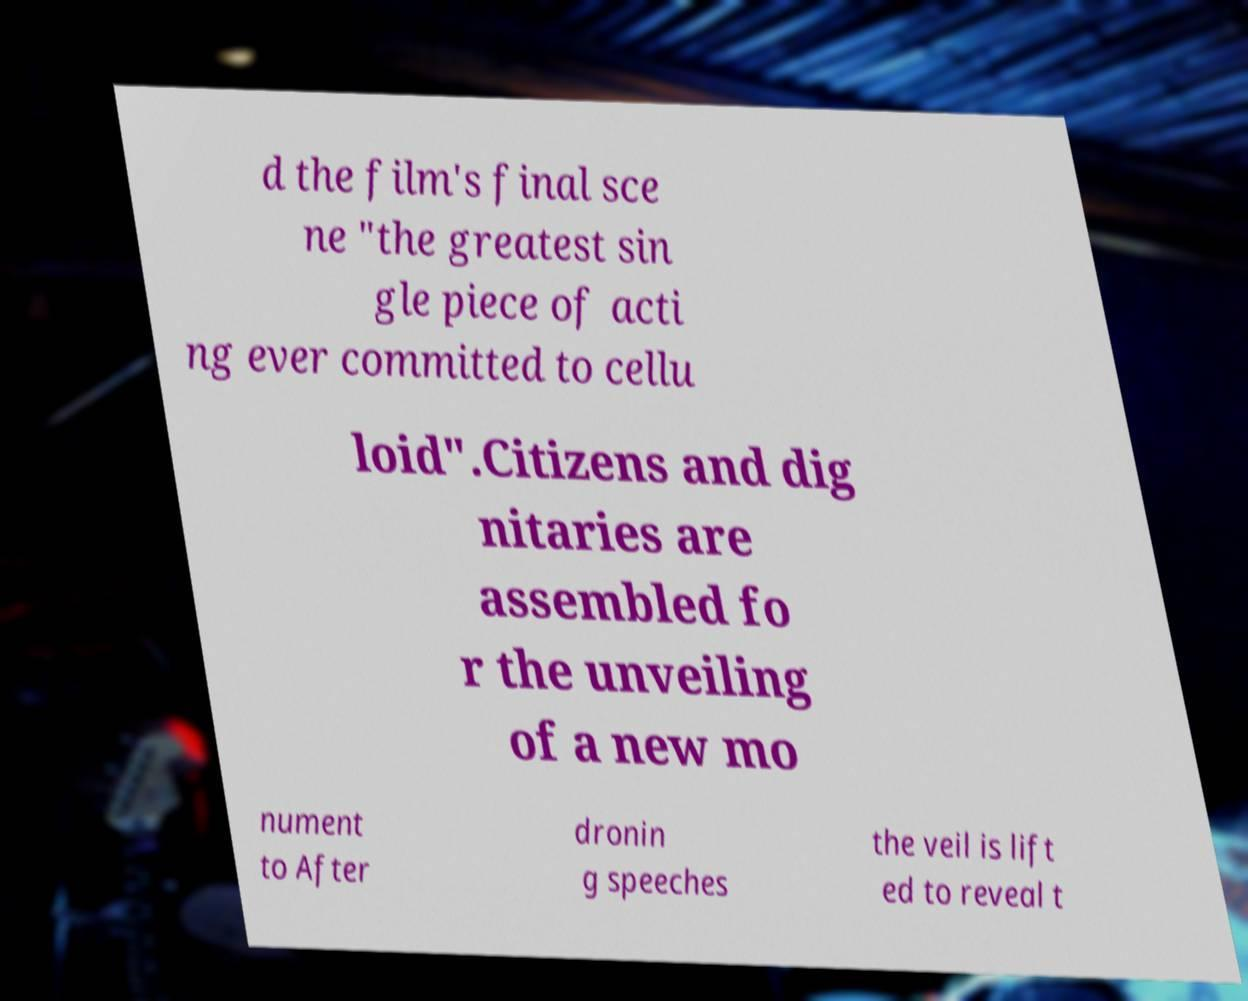Please identify and transcribe the text found in this image. d the film's final sce ne "the greatest sin gle piece of acti ng ever committed to cellu loid".Citizens and dig nitaries are assembled fo r the unveiling of a new mo nument to After dronin g speeches the veil is lift ed to reveal t 